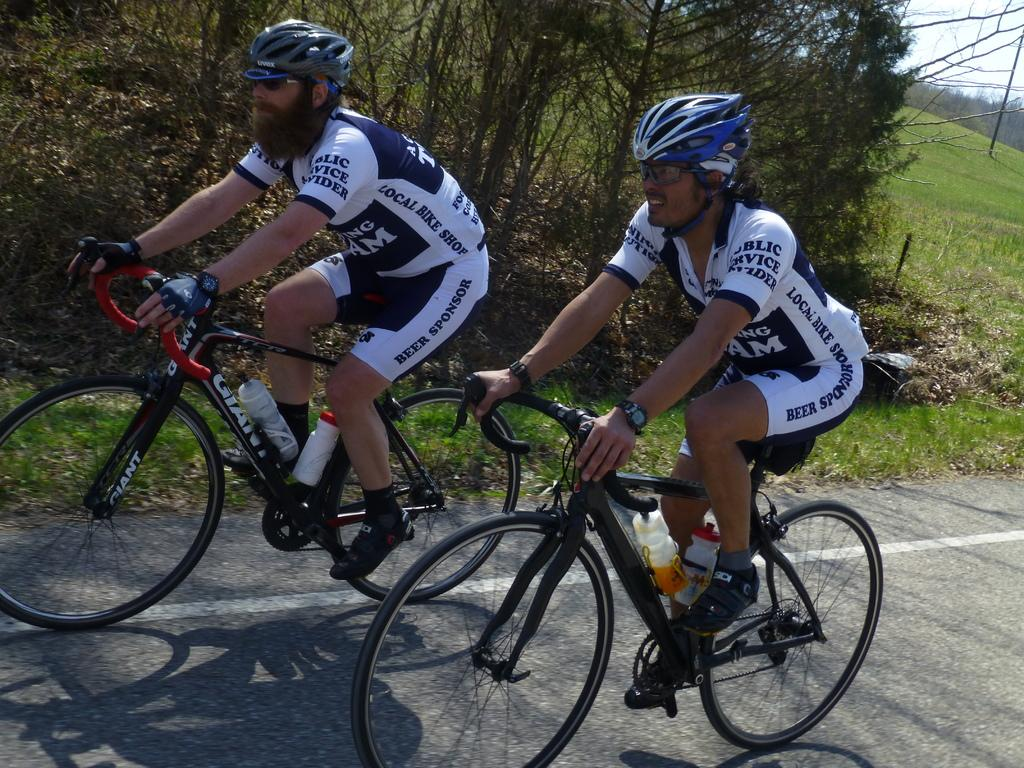What is the main subject of the image? The main subject of the image is persons riding a bicycle in the center of the image. What safety precaution are the persons taking? The persons are wearing helmets. What can be seen in the background of the image? There are trees in the background of the image. What type of terrain is visible in the image? There is grass on the ground in the image. What type of zipper can be seen on the breakfast cart in the image? There is no breakfast cart or zipper present in the image. What type of cart is used to transport the persons riding the bicycle in the image? The persons riding the bicycle are not being transported by a cart; they are riding the bicycle themselves. 